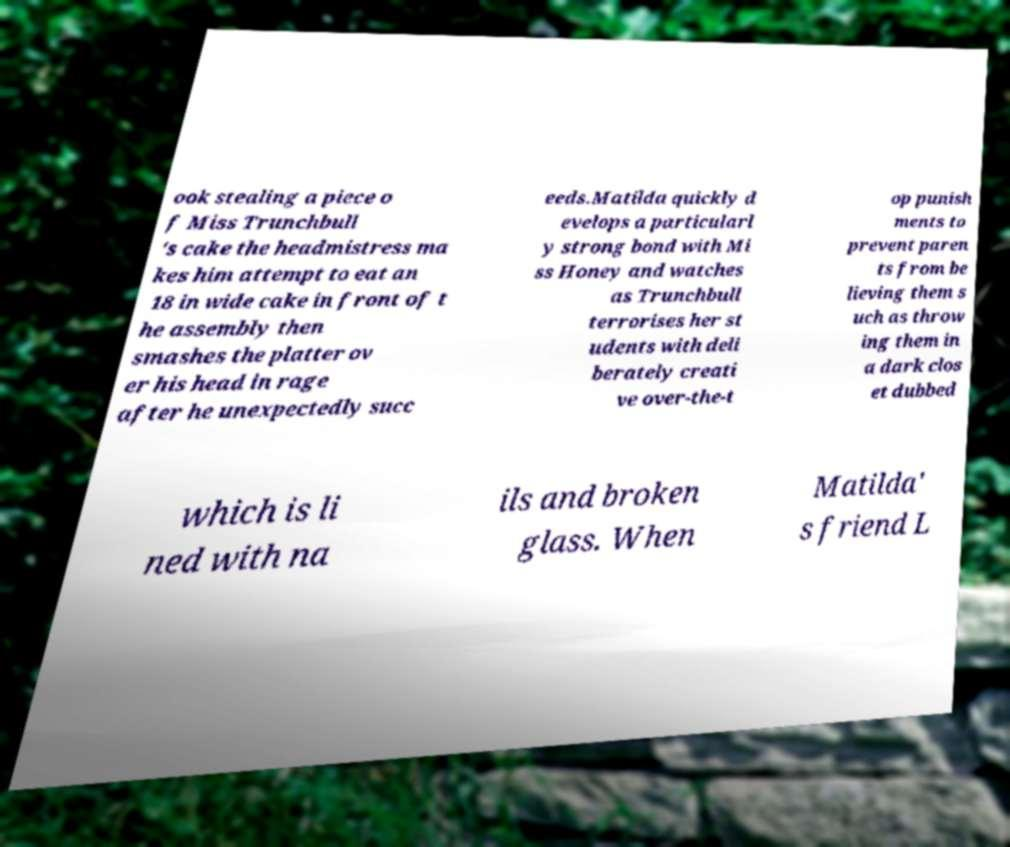Please read and relay the text visible in this image. What does it say? ook stealing a piece o f Miss Trunchbull 's cake the headmistress ma kes him attempt to eat an 18 in wide cake in front of t he assembly then smashes the platter ov er his head in rage after he unexpectedly succ eeds.Matilda quickly d evelops a particularl y strong bond with Mi ss Honey and watches as Trunchbull terrorises her st udents with deli berately creati ve over-the-t op punish ments to prevent paren ts from be lieving them s uch as throw ing them in a dark clos et dubbed which is li ned with na ils and broken glass. When Matilda' s friend L 